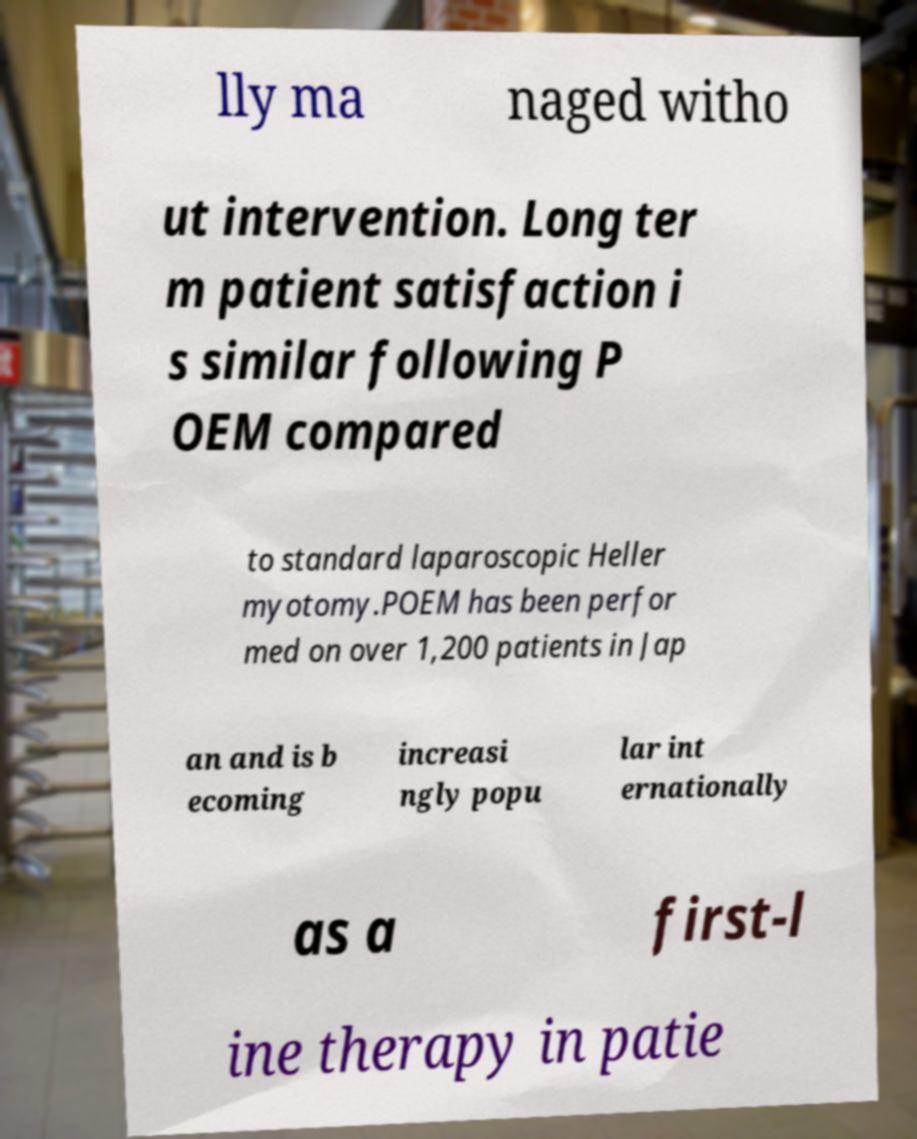There's text embedded in this image that I need extracted. Can you transcribe it verbatim? lly ma naged witho ut intervention. Long ter m patient satisfaction i s similar following P OEM compared to standard laparoscopic Heller myotomy.POEM has been perfor med on over 1,200 patients in Jap an and is b ecoming increasi ngly popu lar int ernationally as a first-l ine therapy in patie 